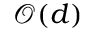<formula> <loc_0><loc_0><loc_500><loc_500>{ \mathcal { O } } ( d )</formula> 